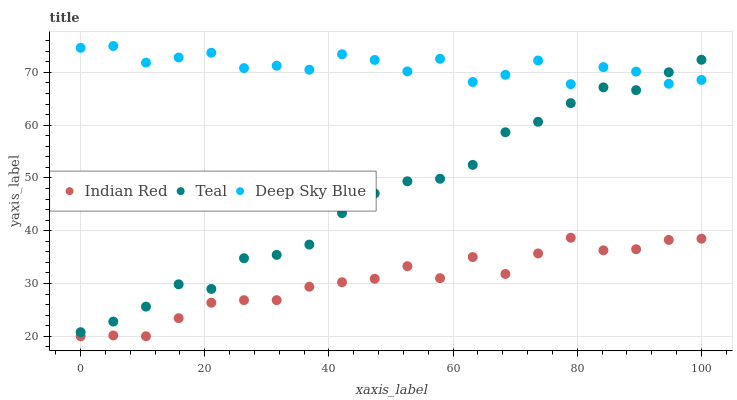Does Indian Red have the minimum area under the curve?
Answer yes or no. Yes. Does Deep Sky Blue have the maximum area under the curve?
Answer yes or no. Yes. Does Teal have the minimum area under the curve?
Answer yes or no. No. Does Teal have the maximum area under the curve?
Answer yes or no. No. Is Teal the smoothest?
Answer yes or no. Yes. Is Deep Sky Blue the roughest?
Answer yes or no. Yes. Is Indian Red the smoothest?
Answer yes or no. No. Is Indian Red the roughest?
Answer yes or no. No. Does Indian Red have the lowest value?
Answer yes or no. Yes. Does Teal have the lowest value?
Answer yes or no. No. Does Deep Sky Blue have the highest value?
Answer yes or no. Yes. Does Teal have the highest value?
Answer yes or no. No. Is Indian Red less than Deep Sky Blue?
Answer yes or no. Yes. Is Deep Sky Blue greater than Indian Red?
Answer yes or no. Yes. Does Deep Sky Blue intersect Teal?
Answer yes or no. Yes. Is Deep Sky Blue less than Teal?
Answer yes or no. No. Is Deep Sky Blue greater than Teal?
Answer yes or no. No. Does Indian Red intersect Deep Sky Blue?
Answer yes or no. No. 